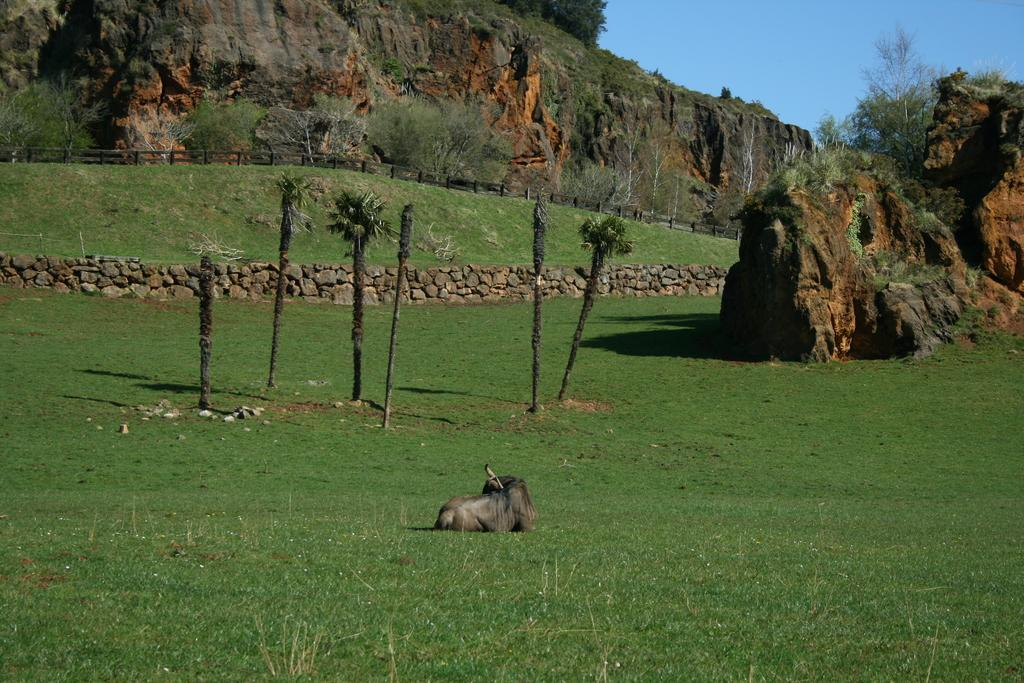Where was the image taken? The image was taken in a park. What can be seen in the foreground of the image? There is grass and an animal in the foreground of the image. What is visible in the middle of the image? There are trees and grass in the middle of the image. What can be seen in the top part of the image? There are trees and a mountain visible in the top part of the image. The sky is also visible in the top part of the image. How many passengers are visible in the image? There are no passengers present in the image. What type of land is the animal standing on in the image? The animal is standing on grass in the image, but there is no specific type of land mentioned. 